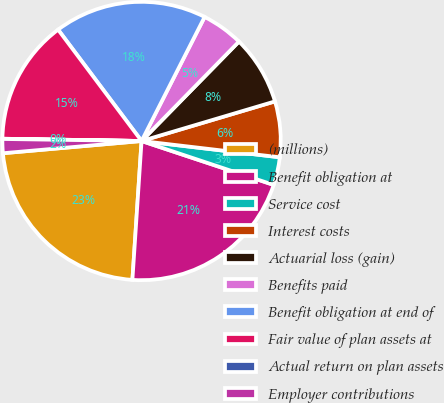Convert chart. <chart><loc_0><loc_0><loc_500><loc_500><pie_chart><fcel>(millions)<fcel>Benefit obligation at<fcel>Service cost<fcel>Interest costs<fcel>Actuarial loss (gain)<fcel>Benefits paid<fcel>Benefit obligation at end of<fcel>Fair value of plan assets at<fcel>Actual return on plan assets<fcel>Employer contributions<nl><fcel>22.55%<fcel>20.94%<fcel>3.24%<fcel>6.46%<fcel>8.07%<fcel>4.85%<fcel>17.72%<fcel>14.5%<fcel>0.03%<fcel>1.63%<nl></chart> 